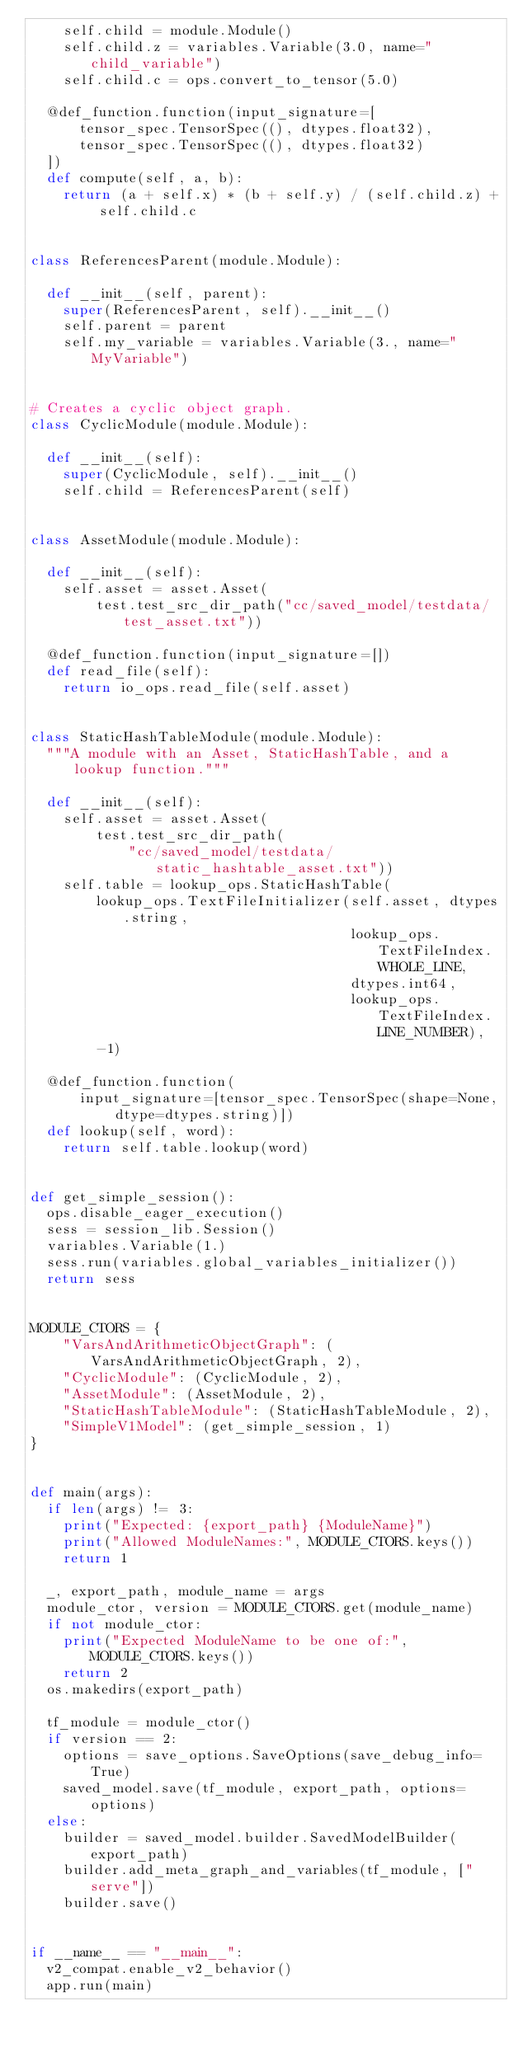<code> <loc_0><loc_0><loc_500><loc_500><_Python_>    self.child = module.Module()
    self.child.z = variables.Variable(3.0, name="child_variable")
    self.child.c = ops.convert_to_tensor(5.0)

  @def_function.function(input_signature=[
      tensor_spec.TensorSpec((), dtypes.float32),
      tensor_spec.TensorSpec((), dtypes.float32)
  ])
  def compute(self, a, b):
    return (a + self.x) * (b + self.y) / (self.child.z) + self.child.c


class ReferencesParent(module.Module):

  def __init__(self, parent):
    super(ReferencesParent, self).__init__()
    self.parent = parent
    self.my_variable = variables.Variable(3., name="MyVariable")


# Creates a cyclic object graph.
class CyclicModule(module.Module):

  def __init__(self):
    super(CyclicModule, self).__init__()
    self.child = ReferencesParent(self)


class AssetModule(module.Module):

  def __init__(self):
    self.asset = asset.Asset(
        test.test_src_dir_path("cc/saved_model/testdata/test_asset.txt"))

  @def_function.function(input_signature=[])
  def read_file(self):
    return io_ops.read_file(self.asset)


class StaticHashTableModule(module.Module):
  """A module with an Asset, StaticHashTable, and a lookup function."""

  def __init__(self):
    self.asset = asset.Asset(
        test.test_src_dir_path(
            "cc/saved_model/testdata/static_hashtable_asset.txt"))
    self.table = lookup_ops.StaticHashTable(
        lookup_ops.TextFileInitializer(self.asset, dtypes.string,
                                       lookup_ops.TextFileIndex.WHOLE_LINE,
                                       dtypes.int64,
                                       lookup_ops.TextFileIndex.LINE_NUMBER),
        -1)

  @def_function.function(
      input_signature=[tensor_spec.TensorSpec(shape=None, dtype=dtypes.string)])
  def lookup(self, word):
    return self.table.lookup(word)


def get_simple_session():
  ops.disable_eager_execution()
  sess = session_lib.Session()
  variables.Variable(1.)
  sess.run(variables.global_variables_initializer())
  return sess


MODULE_CTORS = {
    "VarsAndArithmeticObjectGraph": (VarsAndArithmeticObjectGraph, 2),
    "CyclicModule": (CyclicModule, 2),
    "AssetModule": (AssetModule, 2),
    "StaticHashTableModule": (StaticHashTableModule, 2),
    "SimpleV1Model": (get_simple_session, 1)
}


def main(args):
  if len(args) != 3:
    print("Expected: {export_path} {ModuleName}")
    print("Allowed ModuleNames:", MODULE_CTORS.keys())
    return 1

  _, export_path, module_name = args
  module_ctor, version = MODULE_CTORS.get(module_name)
  if not module_ctor:
    print("Expected ModuleName to be one of:", MODULE_CTORS.keys())
    return 2
  os.makedirs(export_path)

  tf_module = module_ctor()
  if version == 2:
    options = save_options.SaveOptions(save_debug_info=True)
    saved_model.save(tf_module, export_path, options=options)
  else:
    builder = saved_model.builder.SavedModelBuilder(export_path)
    builder.add_meta_graph_and_variables(tf_module, ["serve"])
    builder.save()


if __name__ == "__main__":
  v2_compat.enable_v2_behavior()
  app.run(main)
</code> 